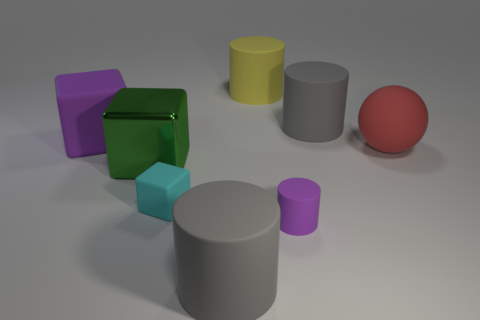Subtract all purple matte cubes. How many cubes are left? 2 Add 2 large green matte blocks. How many objects exist? 10 Subtract all purple cylinders. How many cylinders are left? 3 Subtract all brown cylinders. Subtract all gray cubes. How many cylinders are left? 4 Subtract all spheres. How many objects are left? 7 Add 2 purple balls. How many purple balls exist? 2 Subtract 0 red blocks. How many objects are left? 8 Subtract all tiny red objects. Subtract all matte cylinders. How many objects are left? 4 Add 5 gray cylinders. How many gray cylinders are left? 7 